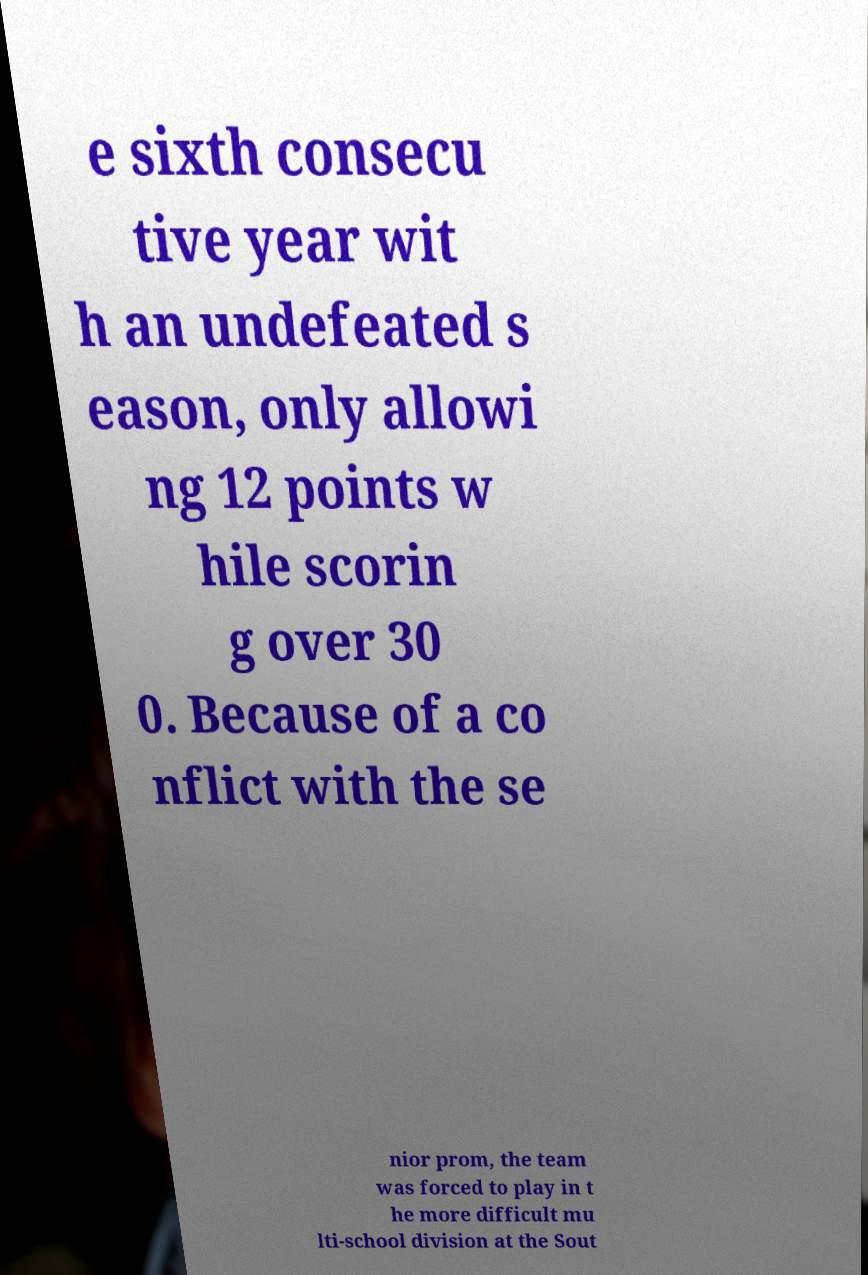Can you read and provide the text displayed in the image?This photo seems to have some interesting text. Can you extract and type it out for me? e sixth consecu tive year wit h an undefeated s eason, only allowi ng 12 points w hile scorin g over 30 0. Because of a co nflict with the se nior prom, the team was forced to play in t he more difficult mu lti-school division at the Sout 